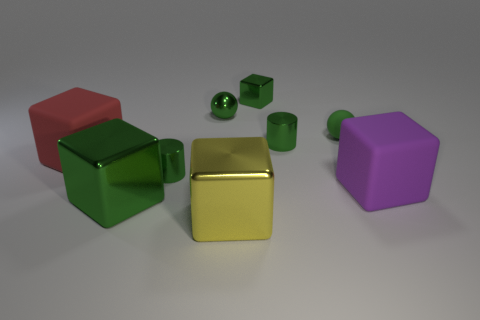Subtract all purple cubes. How many cubes are left? 4 Subtract all large purple matte cubes. How many cubes are left? 4 Subtract all brown cubes. Subtract all yellow balls. How many cubes are left? 5 Add 1 big purple things. How many objects exist? 10 Subtract all cubes. How many objects are left? 4 Subtract all purple rubber objects. Subtract all tiny things. How many objects are left? 3 Add 8 purple objects. How many purple objects are left? 9 Add 8 tiny rubber cylinders. How many tiny rubber cylinders exist? 8 Subtract 0 yellow cylinders. How many objects are left? 9 